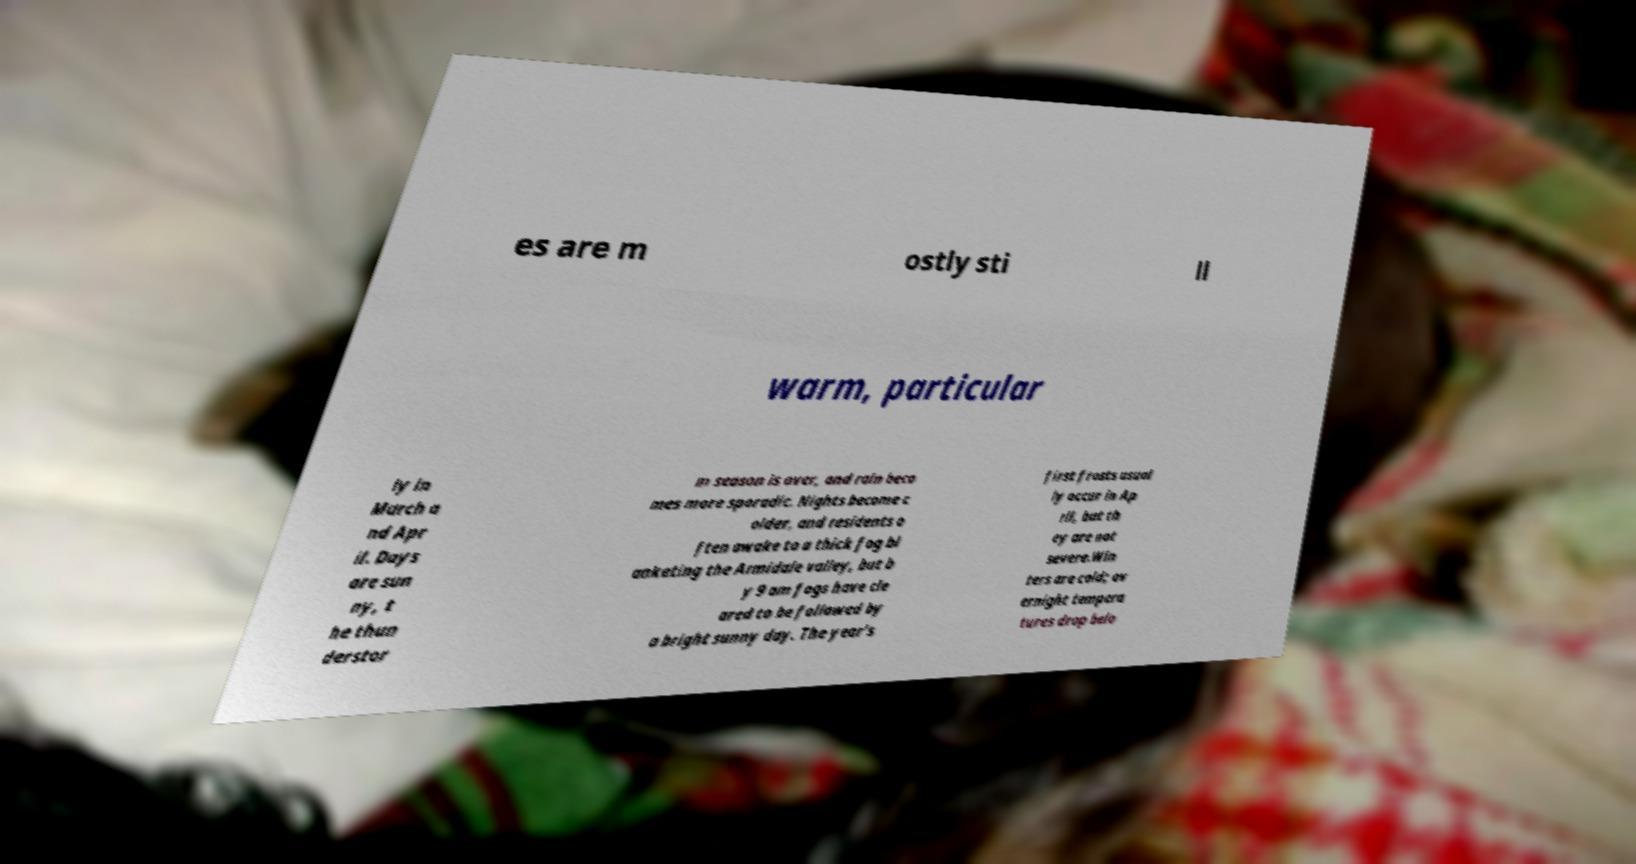Please read and relay the text visible in this image. What does it say? es are m ostly sti ll warm, particular ly in March a nd Apr il. Days are sun ny, t he thun derstor m season is over, and rain beco mes more sporadic. Nights become c older, and residents o ften awake to a thick fog bl anketing the Armidale valley, but b y 9 am fogs have cle ared to be followed by a bright sunny day. The year's first frosts usual ly occur in Ap ril, but th ey are not severe.Win ters are cold; ov ernight tempera tures drop belo 